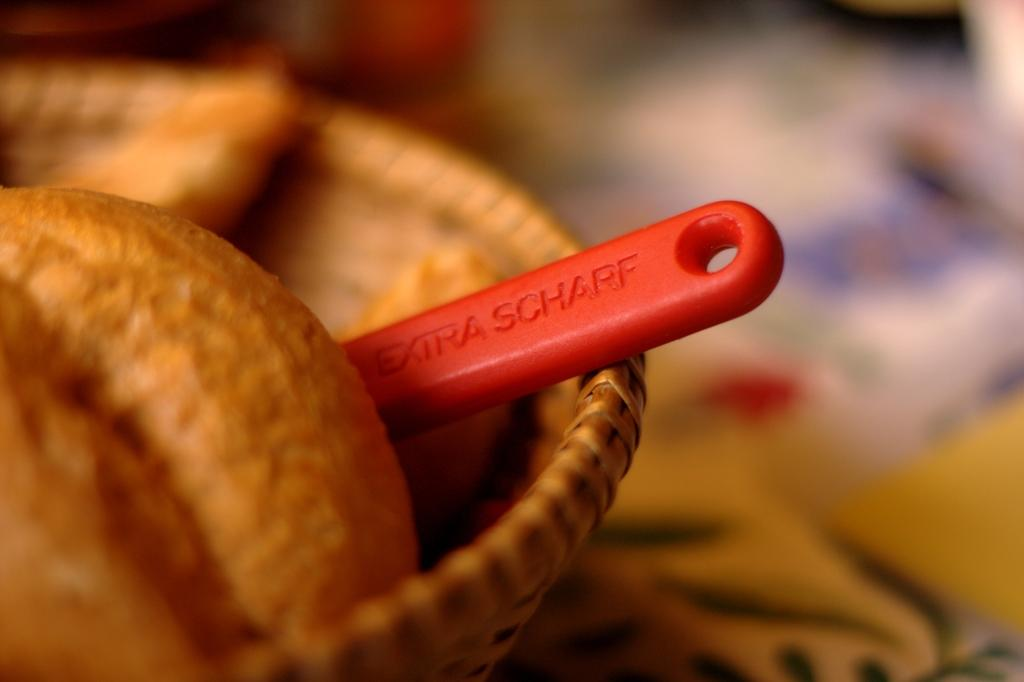What is the main subject of the image? The main subject of the image is food. Is there any utensil visible in the image? There might be a spoon in the basket, but it is not confirmed. If the spoon is present, what can be seen on it? If the spoon is present, there is text on the spoon. How would you describe the clarity of the image on the right side? The right side of the image is blurry. Can you tell me the punchline of the joke being told by the grandfather in the image? There is no joke or grandfather present in the image. How many snails can be seen crawling on the food in the image? There are no snails visible in the image. 